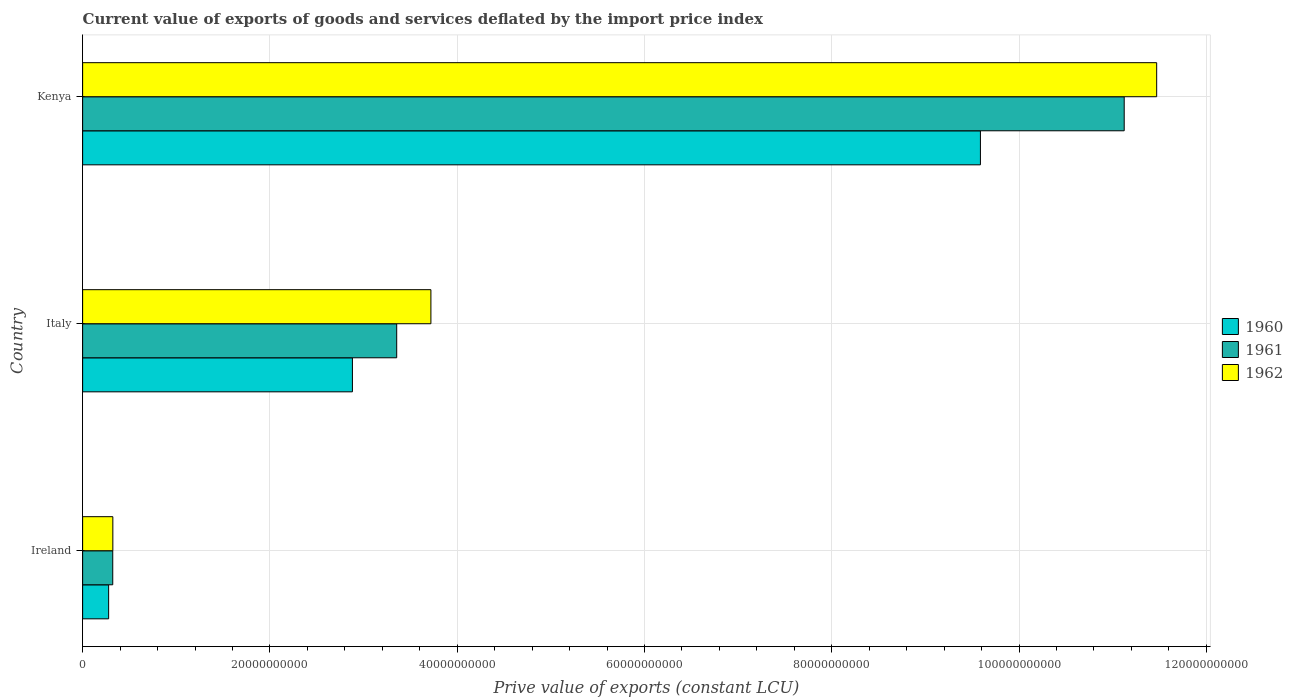How many groups of bars are there?
Your response must be concise. 3. Are the number of bars per tick equal to the number of legend labels?
Your answer should be compact. Yes. How many bars are there on the 2nd tick from the top?
Your answer should be compact. 3. What is the label of the 1st group of bars from the top?
Your response must be concise. Kenya. In how many cases, is the number of bars for a given country not equal to the number of legend labels?
Ensure brevity in your answer.  0. What is the prive value of exports in 1962 in Ireland?
Your answer should be very brief. 3.23e+09. Across all countries, what is the maximum prive value of exports in 1961?
Your response must be concise. 1.11e+11. Across all countries, what is the minimum prive value of exports in 1962?
Make the answer very short. 3.23e+09. In which country was the prive value of exports in 1960 maximum?
Give a very brief answer. Kenya. In which country was the prive value of exports in 1961 minimum?
Offer a very short reply. Ireland. What is the total prive value of exports in 1960 in the graph?
Your answer should be very brief. 1.27e+11. What is the difference between the prive value of exports in 1962 in Italy and that in Kenya?
Your response must be concise. -7.75e+1. What is the difference between the prive value of exports in 1961 in Italy and the prive value of exports in 1962 in Ireland?
Offer a terse response. 3.03e+1. What is the average prive value of exports in 1962 per country?
Make the answer very short. 5.17e+1. What is the difference between the prive value of exports in 1960 and prive value of exports in 1962 in Italy?
Provide a succinct answer. -8.38e+09. In how many countries, is the prive value of exports in 1960 greater than 100000000000 LCU?
Provide a short and direct response. 0. What is the ratio of the prive value of exports in 1961 in Ireland to that in Italy?
Provide a short and direct response. 0.1. Is the prive value of exports in 1962 in Ireland less than that in Kenya?
Your answer should be very brief. Yes. What is the difference between the highest and the second highest prive value of exports in 1960?
Provide a short and direct response. 6.71e+1. What is the difference between the highest and the lowest prive value of exports in 1960?
Offer a terse response. 9.31e+1. Is the sum of the prive value of exports in 1961 in Ireland and Kenya greater than the maximum prive value of exports in 1962 across all countries?
Make the answer very short. No. What does the 1st bar from the top in Italy represents?
Offer a terse response. 1962. How many bars are there?
Make the answer very short. 9. What is the difference between two consecutive major ticks on the X-axis?
Your response must be concise. 2.00e+1. Does the graph contain grids?
Offer a terse response. Yes. How are the legend labels stacked?
Offer a terse response. Vertical. What is the title of the graph?
Provide a succinct answer. Current value of exports of goods and services deflated by the import price index. What is the label or title of the X-axis?
Keep it short and to the point. Prive value of exports (constant LCU). What is the Prive value of exports (constant LCU) in 1960 in Ireland?
Give a very brief answer. 2.78e+09. What is the Prive value of exports (constant LCU) in 1961 in Ireland?
Offer a terse response. 3.22e+09. What is the Prive value of exports (constant LCU) of 1962 in Ireland?
Your response must be concise. 3.23e+09. What is the Prive value of exports (constant LCU) in 1960 in Italy?
Your answer should be very brief. 2.88e+1. What is the Prive value of exports (constant LCU) in 1961 in Italy?
Offer a terse response. 3.35e+1. What is the Prive value of exports (constant LCU) in 1962 in Italy?
Your answer should be compact. 3.72e+1. What is the Prive value of exports (constant LCU) in 1960 in Kenya?
Give a very brief answer. 9.59e+1. What is the Prive value of exports (constant LCU) in 1961 in Kenya?
Ensure brevity in your answer.  1.11e+11. What is the Prive value of exports (constant LCU) in 1962 in Kenya?
Ensure brevity in your answer.  1.15e+11. Across all countries, what is the maximum Prive value of exports (constant LCU) of 1960?
Make the answer very short. 9.59e+1. Across all countries, what is the maximum Prive value of exports (constant LCU) of 1961?
Offer a very short reply. 1.11e+11. Across all countries, what is the maximum Prive value of exports (constant LCU) of 1962?
Your response must be concise. 1.15e+11. Across all countries, what is the minimum Prive value of exports (constant LCU) in 1960?
Give a very brief answer. 2.78e+09. Across all countries, what is the minimum Prive value of exports (constant LCU) in 1961?
Keep it short and to the point. 3.22e+09. Across all countries, what is the minimum Prive value of exports (constant LCU) in 1962?
Offer a very short reply. 3.23e+09. What is the total Prive value of exports (constant LCU) of 1960 in the graph?
Offer a very short reply. 1.27e+11. What is the total Prive value of exports (constant LCU) in 1961 in the graph?
Offer a very short reply. 1.48e+11. What is the total Prive value of exports (constant LCU) of 1962 in the graph?
Keep it short and to the point. 1.55e+11. What is the difference between the Prive value of exports (constant LCU) of 1960 in Ireland and that in Italy?
Provide a succinct answer. -2.60e+1. What is the difference between the Prive value of exports (constant LCU) of 1961 in Ireland and that in Italy?
Your answer should be very brief. -3.03e+1. What is the difference between the Prive value of exports (constant LCU) in 1962 in Ireland and that in Italy?
Make the answer very short. -3.40e+1. What is the difference between the Prive value of exports (constant LCU) of 1960 in Ireland and that in Kenya?
Give a very brief answer. -9.31e+1. What is the difference between the Prive value of exports (constant LCU) in 1961 in Ireland and that in Kenya?
Your answer should be very brief. -1.08e+11. What is the difference between the Prive value of exports (constant LCU) of 1962 in Ireland and that in Kenya?
Give a very brief answer. -1.11e+11. What is the difference between the Prive value of exports (constant LCU) of 1960 in Italy and that in Kenya?
Offer a terse response. -6.71e+1. What is the difference between the Prive value of exports (constant LCU) in 1961 in Italy and that in Kenya?
Offer a terse response. -7.77e+1. What is the difference between the Prive value of exports (constant LCU) in 1962 in Italy and that in Kenya?
Offer a very short reply. -7.75e+1. What is the difference between the Prive value of exports (constant LCU) in 1960 in Ireland and the Prive value of exports (constant LCU) in 1961 in Italy?
Give a very brief answer. -3.08e+1. What is the difference between the Prive value of exports (constant LCU) in 1960 in Ireland and the Prive value of exports (constant LCU) in 1962 in Italy?
Provide a succinct answer. -3.44e+1. What is the difference between the Prive value of exports (constant LCU) in 1961 in Ireland and the Prive value of exports (constant LCU) in 1962 in Italy?
Your answer should be compact. -3.40e+1. What is the difference between the Prive value of exports (constant LCU) in 1960 in Ireland and the Prive value of exports (constant LCU) in 1961 in Kenya?
Offer a terse response. -1.08e+11. What is the difference between the Prive value of exports (constant LCU) of 1960 in Ireland and the Prive value of exports (constant LCU) of 1962 in Kenya?
Your response must be concise. -1.12e+11. What is the difference between the Prive value of exports (constant LCU) of 1961 in Ireland and the Prive value of exports (constant LCU) of 1962 in Kenya?
Make the answer very short. -1.11e+11. What is the difference between the Prive value of exports (constant LCU) in 1960 in Italy and the Prive value of exports (constant LCU) in 1961 in Kenya?
Offer a terse response. -8.24e+1. What is the difference between the Prive value of exports (constant LCU) of 1960 in Italy and the Prive value of exports (constant LCU) of 1962 in Kenya?
Your answer should be compact. -8.59e+1. What is the difference between the Prive value of exports (constant LCU) of 1961 in Italy and the Prive value of exports (constant LCU) of 1962 in Kenya?
Your answer should be compact. -8.12e+1. What is the average Prive value of exports (constant LCU) of 1960 per country?
Your answer should be compact. 4.25e+1. What is the average Prive value of exports (constant LCU) of 1961 per country?
Provide a short and direct response. 4.93e+1. What is the average Prive value of exports (constant LCU) in 1962 per country?
Provide a short and direct response. 5.17e+1. What is the difference between the Prive value of exports (constant LCU) of 1960 and Prive value of exports (constant LCU) of 1961 in Ireland?
Your answer should be compact. -4.39e+08. What is the difference between the Prive value of exports (constant LCU) of 1960 and Prive value of exports (constant LCU) of 1962 in Ireland?
Offer a very short reply. -4.49e+08. What is the difference between the Prive value of exports (constant LCU) of 1961 and Prive value of exports (constant LCU) of 1962 in Ireland?
Ensure brevity in your answer.  -9.94e+06. What is the difference between the Prive value of exports (constant LCU) of 1960 and Prive value of exports (constant LCU) of 1961 in Italy?
Make the answer very short. -4.73e+09. What is the difference between the Prive value of exports (constant LCU) of 1960 and Prive value of exports (constant LCU) of 1962 in Italy?
Provide a succinct answer. -8.38e+09. What is the difference between the Prive value of exports (constant LCU) of 1961 and Prive value of exports (constant LCU) of 1962 in Italy?
Provide a short and direct response. -3.65e+09. What is the difference between the Prive value of exports (constant LCU) in 1960 and Prive value of exports (constant LCU) in 1961 in Kenya?
Your answer should be compact. -1.54e+1. What is the difference between the Prive value of exports (constant LCU) in 1960 and Prive value of exports (constant LCU) in 1962 in Kenya?
Ensure brevity in your answer.  -1.88e+1. What is the difference between the Prive value of exports (constant LCU) in 1961 and Prive value of exports (constant LCU) in 1962 in Kenya?
Offer a terse response. -3.47e+09. What is the ratio of the Prive value of exports (constant LCU) of 1960 in Ireland to that in Italy?
Provide a succinct answer. 0.1. What is the ratio of the Prive value of exports (constant LCU) in 1961 in Ireland to that in Italy?
Ensure brevity in your answer.  0.1. What is the ratio of the Prive value of exports (constant LCU) in 1962 in Ireland to that in Italy?
Make the answer very short. 0.09. What is the ratio of the Prive value of exports (constant LCU) of 1960 in Ireland to that in Kenya?
Ensure brevity in your answer.  0.03. What is the ratio of the Prive value of exports (constant LCU) of 1961 in Ireland to that in Kenya?
Keep it short and to the point. 0.03. What is the ratio of the Prive value of exports (constant LCU) of 1962 in Ireland to that in Kenya?
Your answer should be compact. 0.03. What is the ratio of the Prive value of exports (constant LCU) in 1960 in Italy to that in Kenya?
Offer a very short reply. 0.3. What is the ratio of the Prive value of exports (constant LCU) of 1961 in Italy to that in Kenya?
Make the answer very short. 0.3. What is the ratio of the Prive value of exports (constant LCU) in 1962 in Italy to that in Kenya?
Give a very brief answer. 0.32. What is the difference between the highest and the second highest Prive value of exports (constant LCU) of 1960?
Offer a very short reply. 6.71e+1. What is the difference between the highest and the second highest Prive value of exports (constant LCU) in 1961?
Keep it short and to the point. 7.77e+1. What is the difference between the highest and the second highest Prive value of exports (constant LCU) of 1962?
Offer a very short reply. 7.75e+1. What is the difference between the highest and the lowest Prive value of exports (constant LCU) in 1960?
Offer a very short reply. 9.31e+1. What is the difference between the highest and the lowest Prive value of exports (constant LCU) in 1961?
Offer a terse response. 1.08e+11. What is the difference between the highest and the lowest Prive value of exports (constant LCU) in 1962?
Provide a succinct answer. 1.11e+11. 